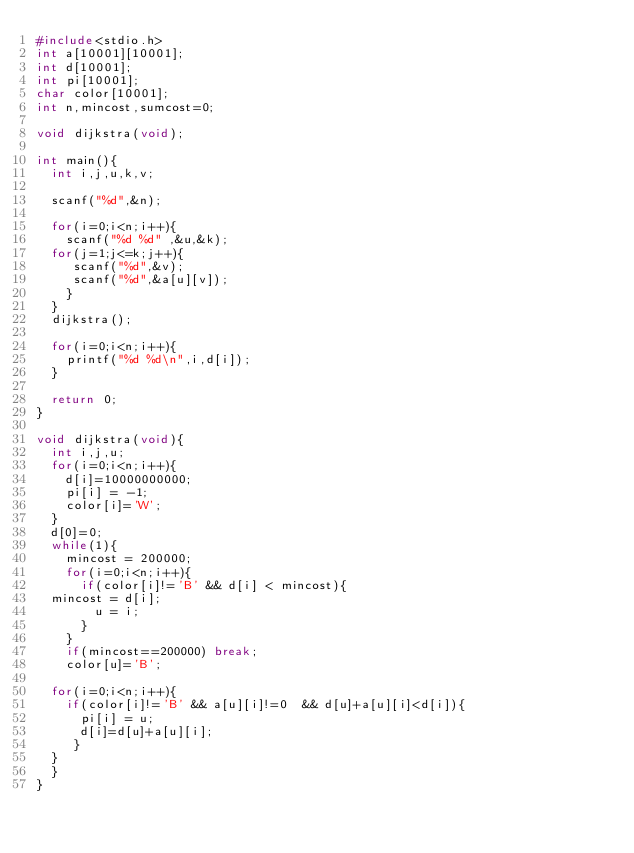Convert code to text. <code><loc_0><loc_0><loc_500><loc_500><_C_>#include<stdio.h>
int a[10001][10001];
int d[10001];
int pi[10001];
char color[10001];
int n,mincost,sumcost=0;

void dijkstra(void);

int main(){
  int i,j,u,k,v;

  scanf("%d",&n);

  for(i=0;i<n;i++){
    scanf("%d %d" ,&u,&k);      
  for(j=1;j<=k;j++){
     scanf("%d",&v);
     scanf("%d",&a[u][v]);   
    }
  }
  dijkstra();

  for(i=0;i<n;i++){
    printf("%d %d\n",i,d[i]);
  }

  return 0;
}

void dijkstra(void){
  int i,j,u;
  for(i=0;i<n;i++){
    d[i]=10000000000;
    pi[i] = -1;
    color[i]='W';
  }
  d[0]=0;
  while(1){
    mincost = 200000;
    for(i=0;i<n;i++){
      if(color[i]!='B' && d[i] < mincost){
	mincost = d[i];
        u = i;
      }
    }
    if(mincost==200000) break;
    color[u]='B';
  
  for(i=0;i<n;i++){
    if(color[i]!='B' && a[u][i]!=0  && d[u]+a[u][i]<d[i]){
      pi[i] = u;
      d[i]=d[u]+a[u][i];
     }
  }
  }
}</code> 